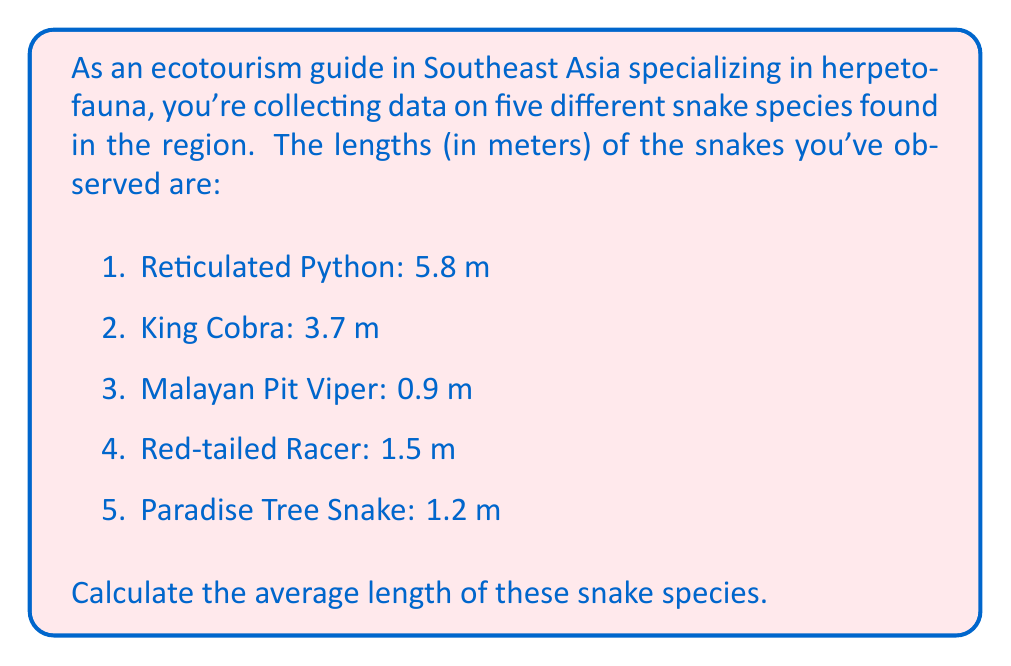What is the answer to this math problem? To calculate the average length of the snake species, we need to follow these steps:

1. Sum up all the lengths of the snakes:
   $$5.8 + 3.7 + 0.9 + 1.5 + 1.2 = 13.1\text{ m}$$

2. Count the total number of snake species:
   There are 5 different species in our data set.

3. Calculate the average by dividing the sum of lengths by the number of species:
   $$\text{Average} = \frac{\text{Sum of lengths}}{\text{Number of species}}$$
   
   $$\text{Average} = \frac{13.1}{5} = 2.62\text{ m}$$

Therefore, the average length of these five snake species is 2.62 meters.
Answer: $2.62\text{ m}$ 